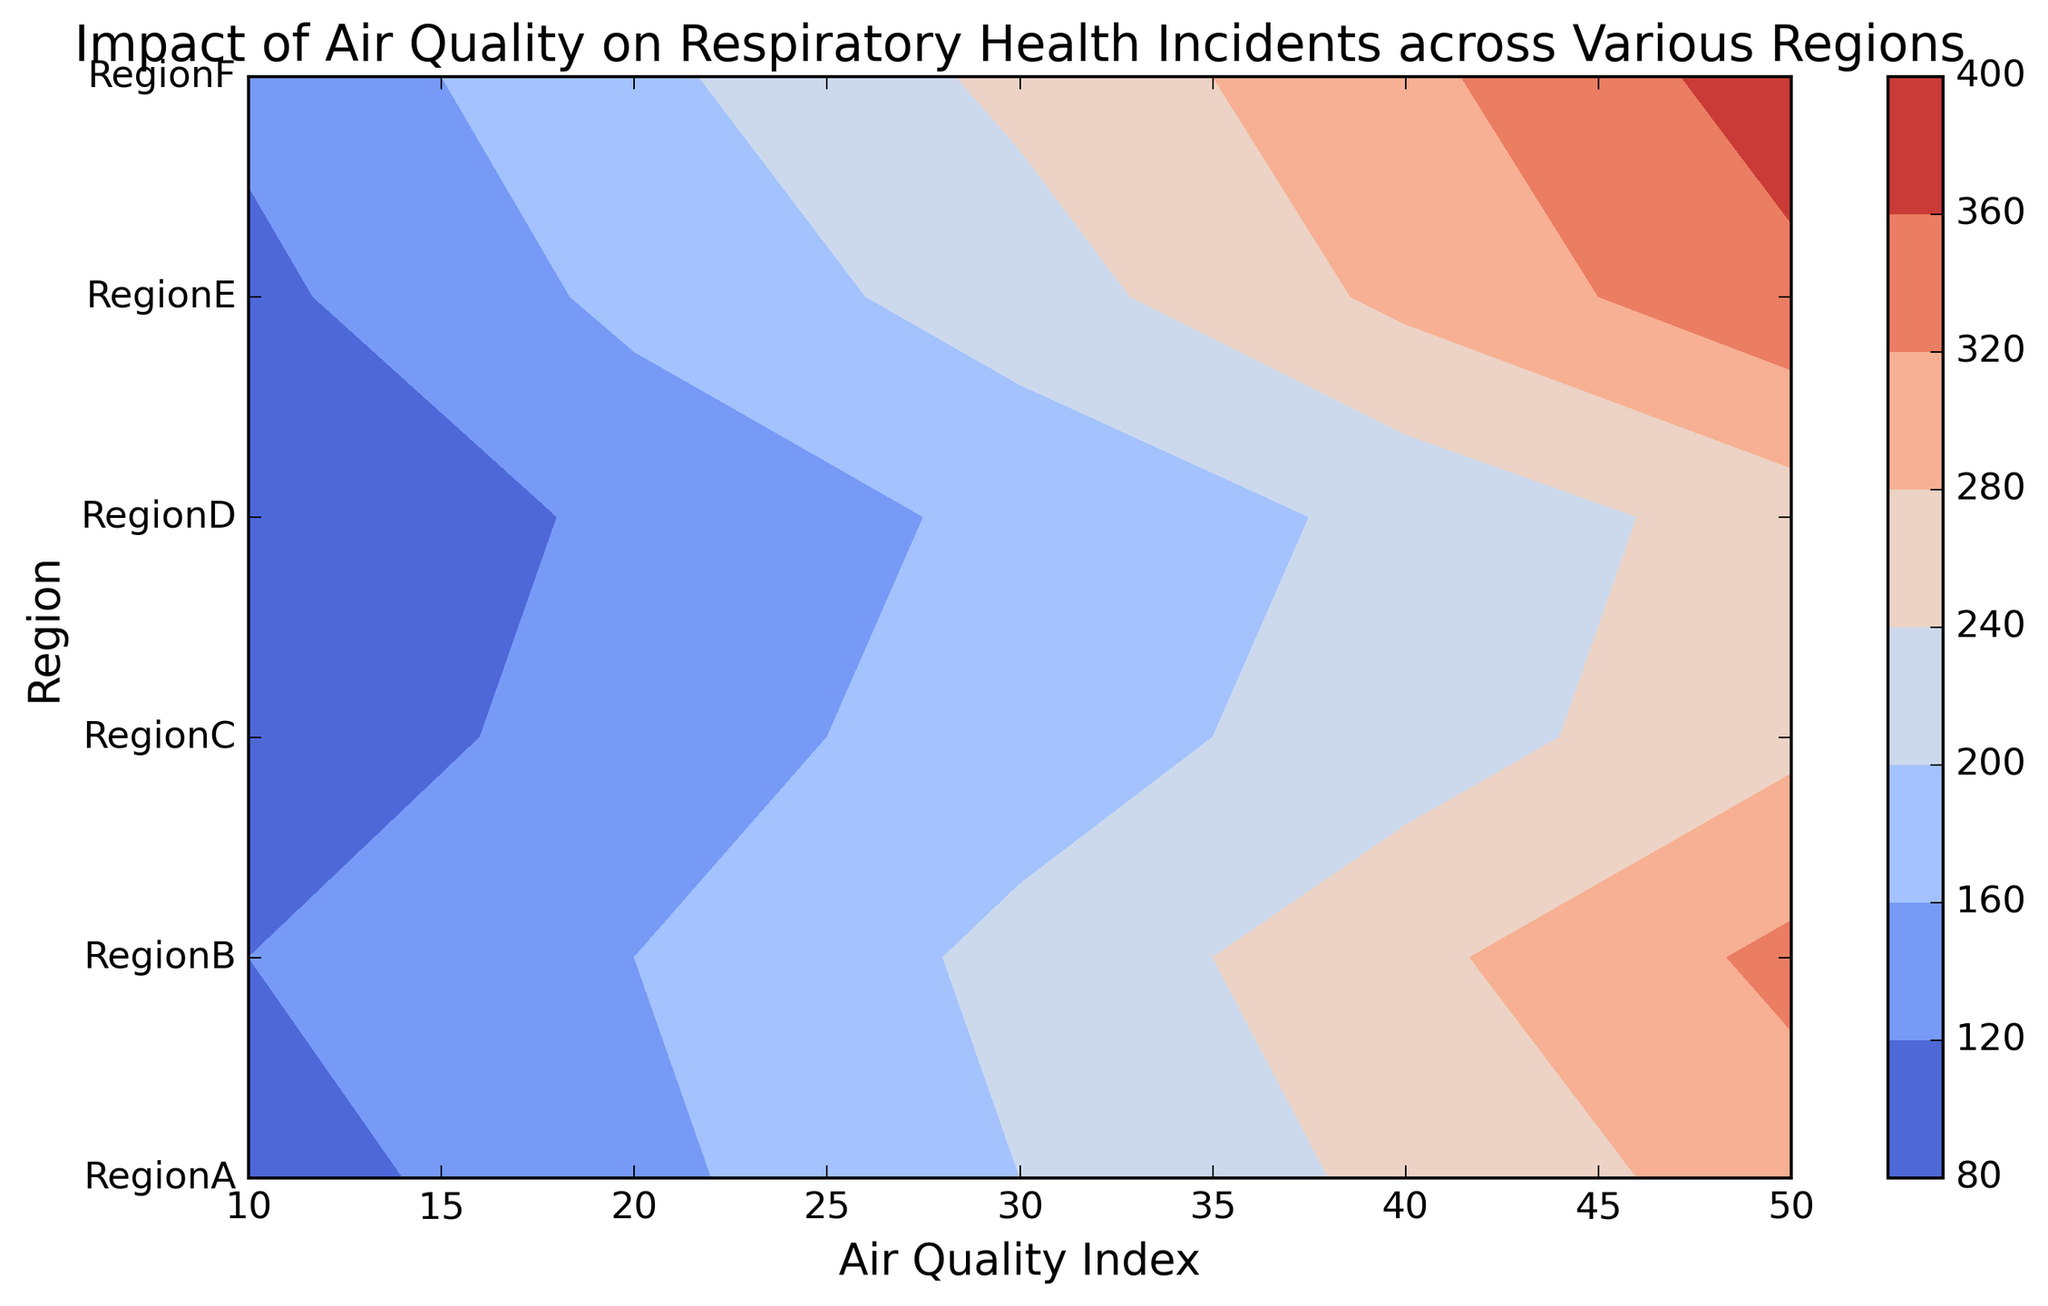What region has the highest number of respiratory incidents when the Air Quality Index is 50? By examining the contour plot at the Air Quality Index of 50, we can identify which region shows the highest value on the color scale.
Answer: RegionF Which region shows the most significant increase in respiratory incidents from an Air Quality Index of 10 to 50? To determine this, we need to compare the change in respiratory incidents between these indexes across all regions. RegionF, for example, goes from 130 to 380 (a change of 250), while other regions show lesser changes.
Answer: RegionF What is the color indicating the lowest respiratory incidents for any region? The lowest respiratory incidents should correspond to the lightest color on the plot. Looking at the plot, the lightest region corresponds to 80 incidents in RegionD when the Air Quality Index is 10.
Answer: Lightest shade/Gray Which regions have more than 300 respiratory incidents when the Air Quality Index is 50? By observing the contour lines and values at the Air Quality Index of 50, we can see which regions cross the 300 incidents threshold.
Answer: RegionB, RegionE, RegionF How does the number of respiratory incidents change as the Air Quality Index increases for RegionA? Follow the contour lines for RegionA from 10 to 50, noting the values (100, 150, 200, 250, 300), indicating a linear increase with the deteriorating air quality.
Answer: Linear increase Which region has fewer respiratory incidents at an Air Quality Index of 40, RegionB or RegionC? Check the contour values at the Air Quality Index of 40 for both regions. RegionB shows 270 incidents, while RegionC shows 220 incidents.
Answer: RegionC What is the average number of respiratory incidents reported across all regions when the Air Quality Index is 20? Calculate the mean of respiratory incidents across all regions for an Air Quality Index of 20 (150 + 160 + 140 + 130 + 170 + 190). The sum is 940, and the average is 940/6 = 156.67.
Answer: 156.67 Which region has the steepest increase in respiratory incidents as the Air Quality Index rises from 30 to 50? Compare the increase in respiratory incidents between these two points for each region. RegionE shows an increase from 220 to 350 (130 incidents).
Answer: RegionE Do all regions display a similar trend of increasing respiratory incidents with worsening air quality? Observe the contour lines for all regions to see if they consistently show an increase in respiratory incidents as the air quality index increases. Each region does follow an increasing trend.
Answer: Yes 